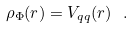Convert formula to latex. <formula><loc_0><loc_0><loc_500><loc_500>\rho _ { \Phi } ( r ) = V _ { q q } ( r ) \ .</formula> 